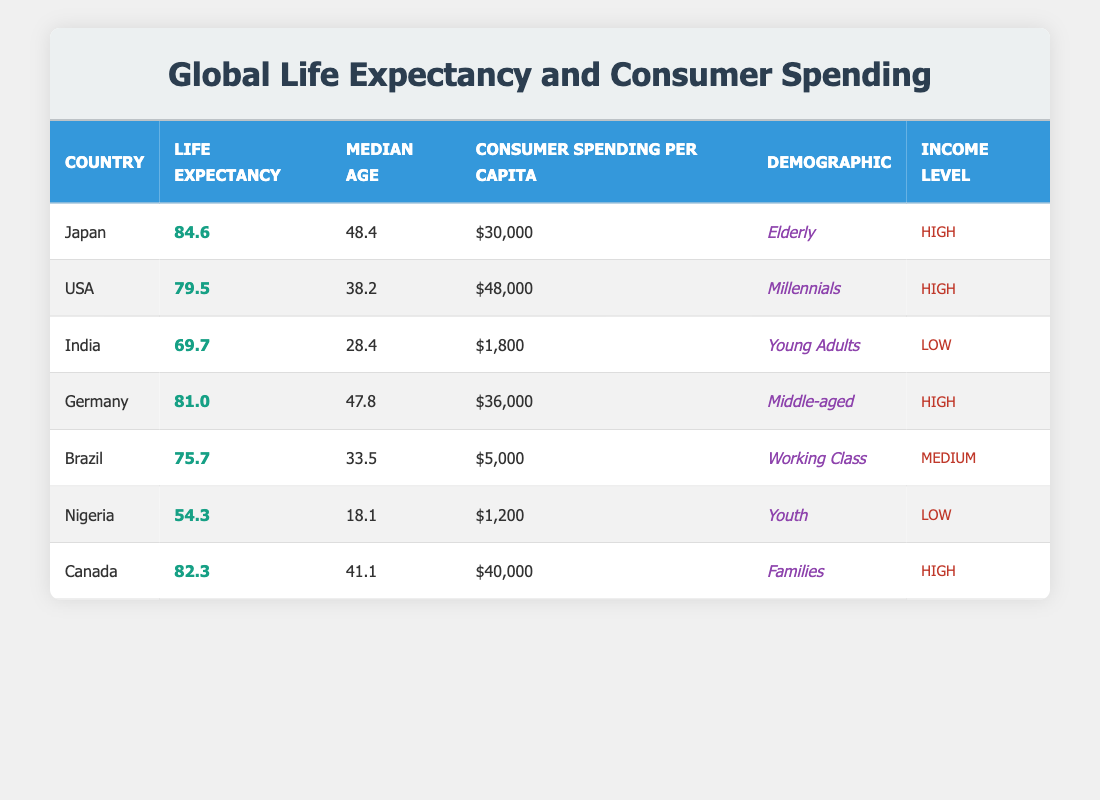What is the life expectancy of Japan? The table directly lists Japan with a life expectancy value of 84.6.
Answer: 84.6 Which country has the highest consumer spending per capita? By comparing the consumer spending per capita values across all countries, the USA has the highest at $48,000.
Answer: USA Is the life expectancy of Nigeria greater than that of Brazil? The life expectancy of Nigeria is 54.3, while Brazil's is 75.7. Since 54.3 is not greater than 75.7, the statement is false.
Answer: No What is the average life expectancy of all the countries listed? To find the average, sum the life expectancies: 84.6 + 79.5 + 69.7 + 81.0 + 75.7 + 54.3 + 82.3 = 427.1. There are 7 countries, so the average is 427.1 / 7 = 61.0.
Answer: 61.0 What is the median age of Germany? The table specifies that Germany has a median age of 47.8 years.
Answer: 47.8 Do any countries with low income levels have a life expectancy greater than 70? The countries with low income levels are India and Nigeria, with life expectancies of 69.7 and 54.3, respectively. Neither exceeds 70, so the answer is no.
Answer: No Calculate the difference in consumer spending per capita between Japan and Canada. Japan's consumer spending is $30,000 and Canada's is $40,000. The difference is $40,000 - $30,000 = $10,000.
Answer: $10,000 Which demographic in the USA has the highest life expectancy? The table shows that the demographic in the USA is 'Millennials' and their life expectancy is 79.5. There are no other demographics listed in the USA, so this is the answer.
Answer: Millennials How many countries have a life expectancy below 70? Looking through the life expectancies, India (69.7) and Nigeria (54.3) are below 70. Thus, there are 2 countries with a life expectancy below 70.
Answer: 2 